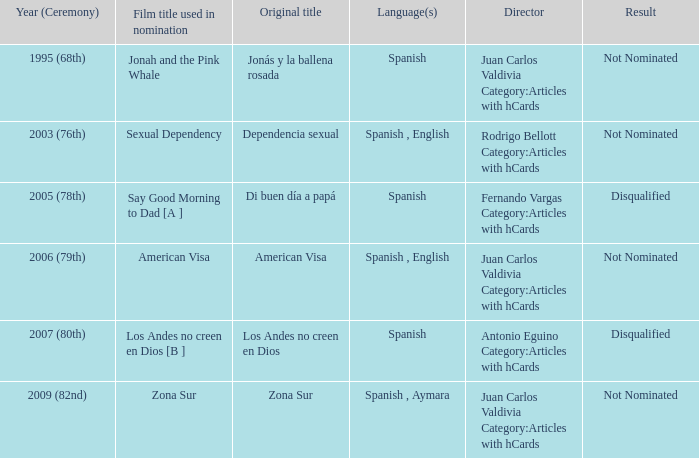What is the film title of dependencia sexual that was utilized for its nomination? Sexual Dependency. 